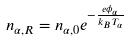Convert formula to latex. <formula><loc_0><loc_0><loc_500><loc_500>n _ { \alpha , R } = n _ { \alpha , 0 } e ^ { - \frac { e \phi _ { \alpha } } { k _ { B } T _ { \alpha } } }</formula> 